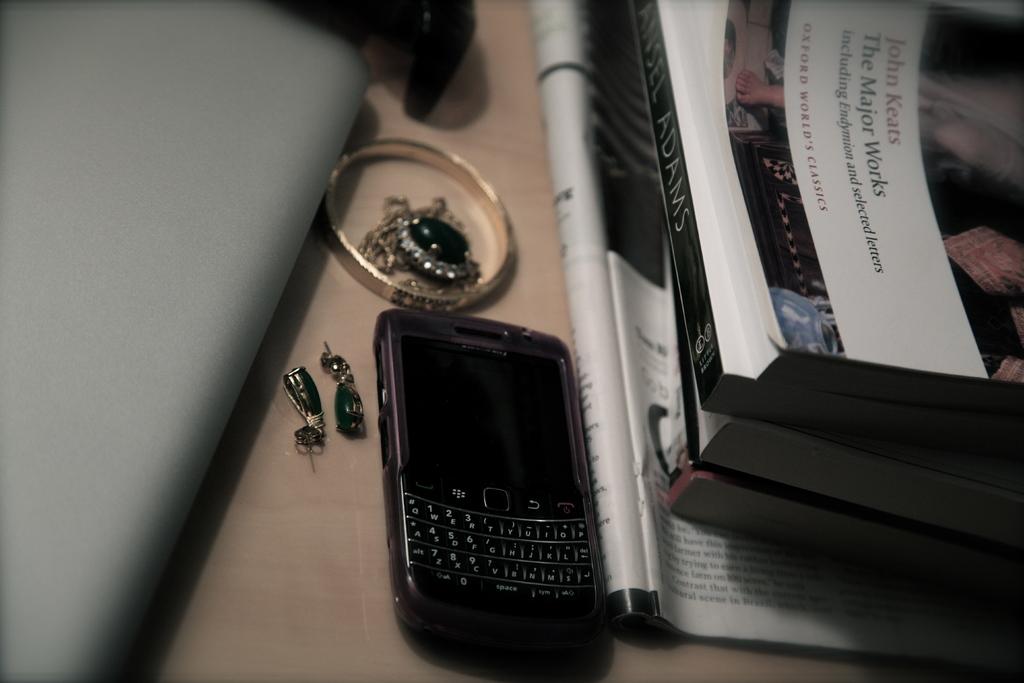What is the title of the book on the desk?
Give a very brief answer. The major works. What is the last name of the author?
Provide a short and direct response. Keats. 